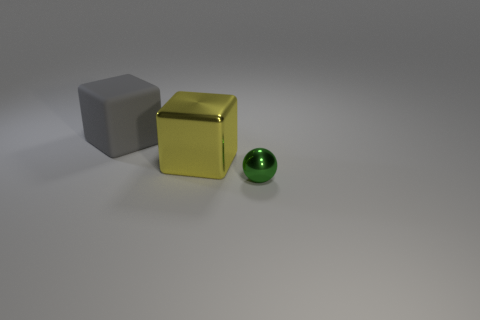Add 2 tiny things. How many objects exist? 5 Subtract all yellow cubes. How many cubes are left? 1 Subtract 1 blocks. How many blocks are left? 1 Subtract all purple blocks. Subtract all blue balls. How many blocks are left? 2 Subtract all cubes. How many objects are left? 1 Subtract all big gray rubber objects. Subtract all big yellow metal blocks. How many objects are left? 1 Add 1 large yellow objects. How many large yellow objects are left? 2 Add 3 matte cylinders. How many matte cylinders exist? 3 Subtract 0 yellow balls. How many objects are left? 3 